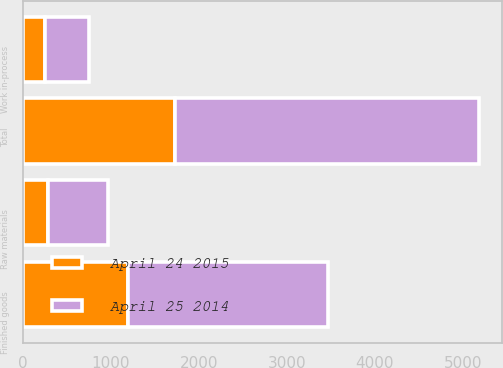Convert chart to OTSL. <chart><loc_0><loc_0><loc_500><loc_500><stacked_bar_chart><ecel><fcel>Finished goods<fcel>Work in-process<fcel>Raw materials<fcel>Total<nl><fcel>April 25 2014<fcel>2268<fcel>509<fcel>686<fcel>3463<nl><fcel>April 24 2015<fcel>1196<fcel>247<fcel>282<fcel>1725<nl></chart> 